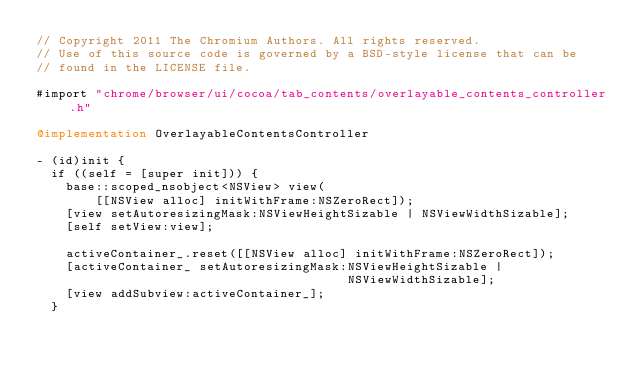<code> <loc_0><loc_0><loc_500><loc_500><_ObjectiveC_>// Copyright 2011 The Chromium Authors. All rights reserved.
// Use of this source code is governed by a BSD-style license that can be
// found in the LICENSE file.

#import "chrome/browser/ui/cocoa/tab_contents/overlayable_contents_controller.h"

@implementation OverlayableContentsController

- (id)init {
  if ((self = [super init])) {
    base::scoped_nsobject<NSView> view(
        [[NSView alloc] initWithFrame:NSZeroRect]);
    [view setAutoresizingMask:NSViewHeightSizable | NSViewWidthSizable];
    [self setView:view];

    activeContainer_.reset([[NSView alloc] initWithFrame:NSZeroRect]);
    [activeContainer_ setAutoresizingMask:NSViewHeightSizable |
                                          NSViewWidthSizable];
    [view addSubview:activeContainer_];
  }</code> 